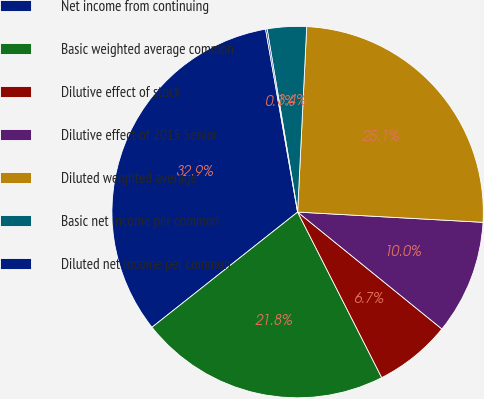Convert chart. <chart><loc_0><loc_0><loc_500><loc_500><pie_chart><fcel>Net income from continuing<fcel>Basic weighted average common<fcel>Dilutive effect of stock<fcel>Dilutive effect of 2015 Senior<fcel>Diluted weighted average<fcel>Basic net income per common<fcel>Diluted net income per common<nl><fcel>32.89%<fcel>21.83%<fcel>6.68%<fcel>9.96%<fcel>25.1%<fcel>3.41%<fcel>0.13%<nl></chart> 